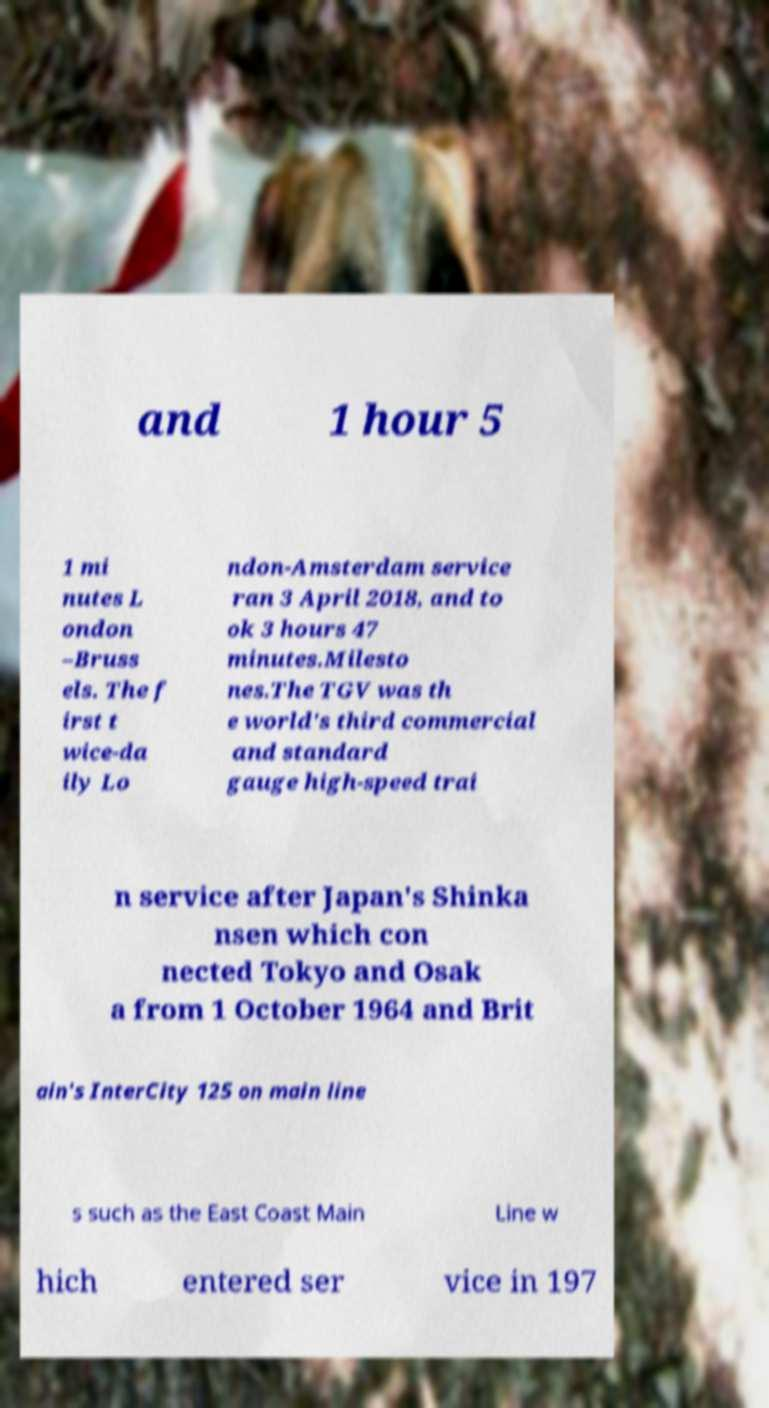For documentation purposes, I need the text within this image transcribed. Could you provide that? and 1 hour 5 1 mi nutes L ondon –Bruss els. The f irst t wice-da ily Lo ndon-Amsterdam service ran 3 April 2018, and to ok 3 hours 47 minutes.Milesto nes.The TGV was th e world's third commercial and standard gauge high-speed trai n service after Japan's Shinka nsen which con nected Tokyo and Osak a from 1 October 1964 and Brit ain's InterCity 125 on main line s such as the East Coast Main Line w hich entered ser vice in 197 